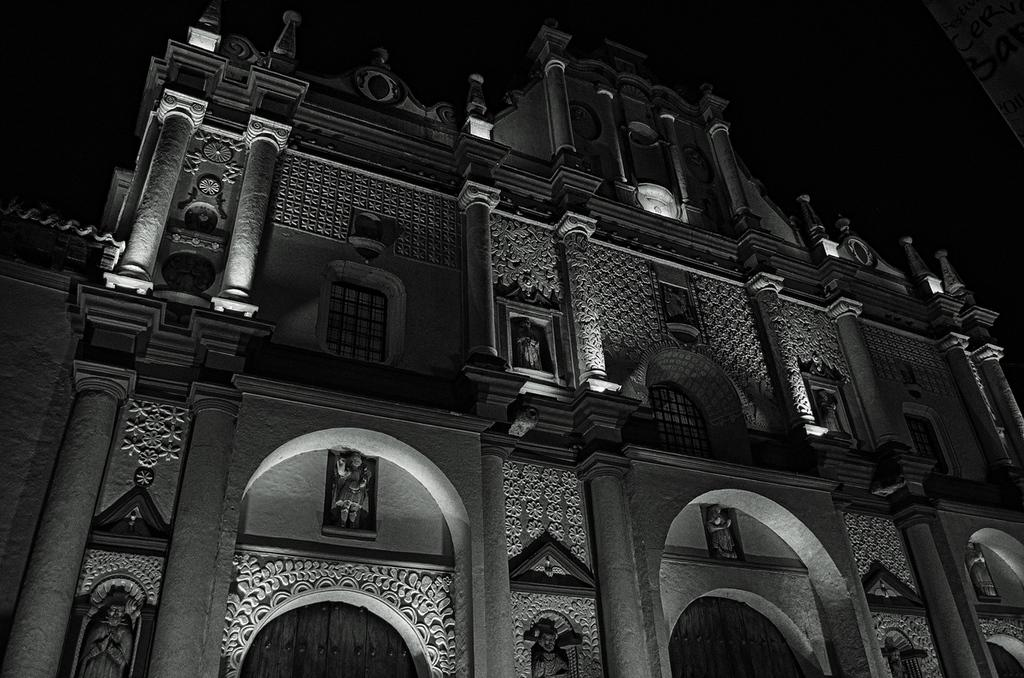What type of structure can be seen in the image? There is a building in the image. Are there any decorative elements on the building? Yes, there are statues present on the building. How many girls are standing next to the owl in the image? There are no girls or owls present in the image; it only features a building with statues. 